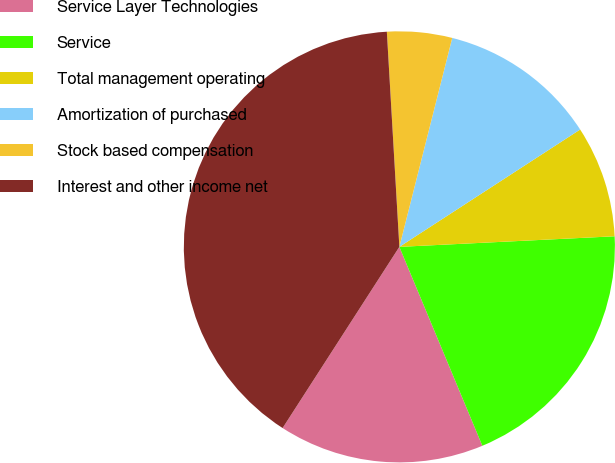Convert chart. <chart><loc_0><loc_0><loc_500><loc_500><pie_chart><fcel>Service Layer Technologies<fcel>Service<fcel>Total management operating<fcel>Amortization of purchased<fcel>Stock based compensation<fcel>Interest and other income net<nl><fcel>15.4%<fcel>19.49%<fcel>8.38%<fcel>11.89%<fcel>4.87%<fcel>39.96%<nl></chart> 